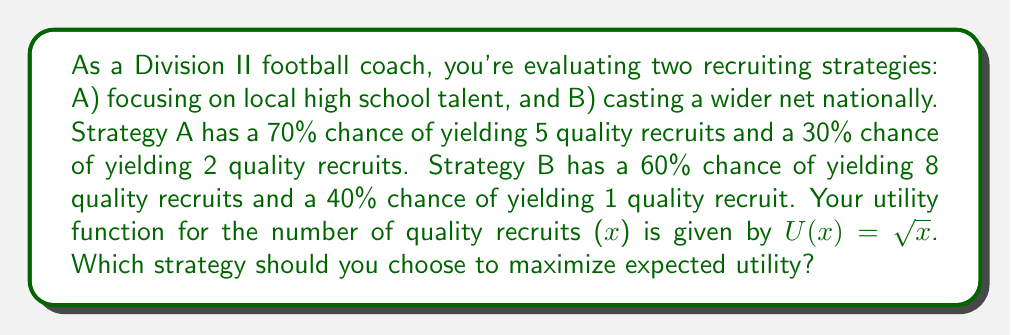What is the answer to this math problem? To solve this problem, we need to calculate the expected utility for each strategy and compare them:

1. Calculate the expected utility for Strategy A:
   $$E[U(A)] = 0.70 \cdot U(5) + 0.30 \cdot U(2)$$
   $$E[U(A)] = 0.70 \cdot \sqrt{5} + 0.30 \cdot \sqrt{2}$$
   $$E[U(A)] = 0.70 \cdot 2.236 + 0.30 \cdot 1.414$$
   $$E[U(A)] = 1.565 + 0.424 = 1.989$$

2. Calculate the expected utility for Strategy B:
   $$E[U(B)] = 0.60 \cdot U(8) + 0.40 \cdot U(1)$$
   $$E[U(B)] = 0.60 \cdot \sqrt{8} + 0.40 \cdot \sqrt{1}$$
   $$E[U(B)] = 0.60 \cdot 2.828 + 0.40 \cdot 1$$
   $$E[U(B)] = 1.697 + 0.400 = 2.097$$

3. Compare the expected utilities:
   Strategy B has a higher expected utility (2.097) compared to Strategy A (1.989).

The risk-reward tradeoff is evident in this scenario. Strategy A is more conservative with a higher probability of moderate success, while Strategy B is riskier but offers the potential for greater rewards. The utility function $U(x) = \sqrt{x}$ reflects diminishing marginal returns, which means that the value of additional recruits decreases as the total number increases. This utility function balances the risk and potential reward, favoring Strategy B in this case.
Answer: Strategy B should be chosen to maximize expected utility, with an expected utility of 2.097 compared to 1.989 for Strategy A. 